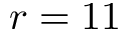<formula> <loc_0><loc_0><loc_500><loc_500>r = 1 1</formula> 